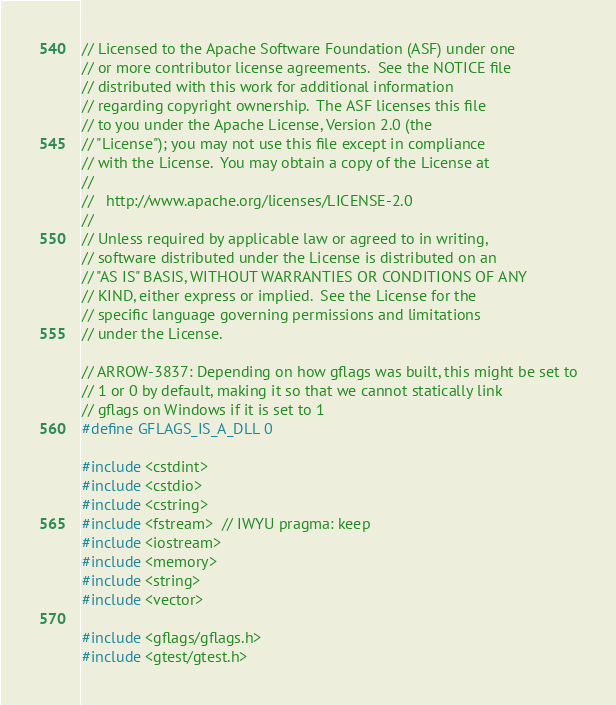<code> <loc_0><loc_0><loc_500><loc_500><_C++_>// Licensed to the Apache Software Foundation (ASF) under one
// or more contributor license agreements.  See the NOTICE file
// distributed with this work for additional information
// regarding copyright ownership.  The ASF licenses this file
// to you under the Apache License, Version 2.0 (the
// "License"); you may not use this file except in compliance
// with the License.  You may obtain a copy of the License at
//
//   http://www.apache.org/licenses/LICENSE-2.0
//
// Unless required by applicable law or agreed to in writing,
// software distributed under the License is distributed on an
// "AS IS" BASIS, WITHOUT WARRANTIES OR CONDITIONS OF ANY
// KIND, either express or implied.  See the License for the
// specific language governing permissions and limitations
// under the License.

// ARROW-3837: Depending on how gflags was built, this might be set to
// 1 or 0 by default, making it so that we cannot statically link
// gflags on Windows if it is set to 1
#define GFLAGS_IS_A_DLL 0

#include <cstdint>
#include <cstdio>
#include <cstring>
#include <fstream>  // IWYU pragma: keep
#include <iostream>
#include <memory>
#include <string>
#include <vector>

#include <gflags/gflags.h>
#include <gtest/gtest.h>
</code> 